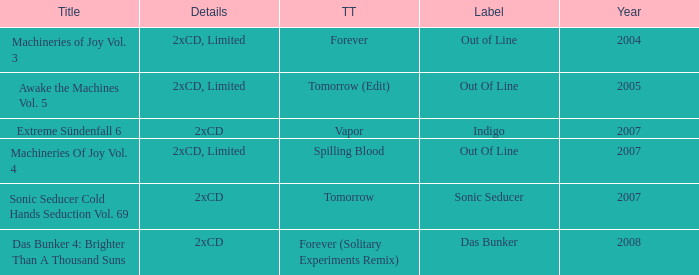What average year contains the title of machineries of joy vol. 4? 2007.0. 